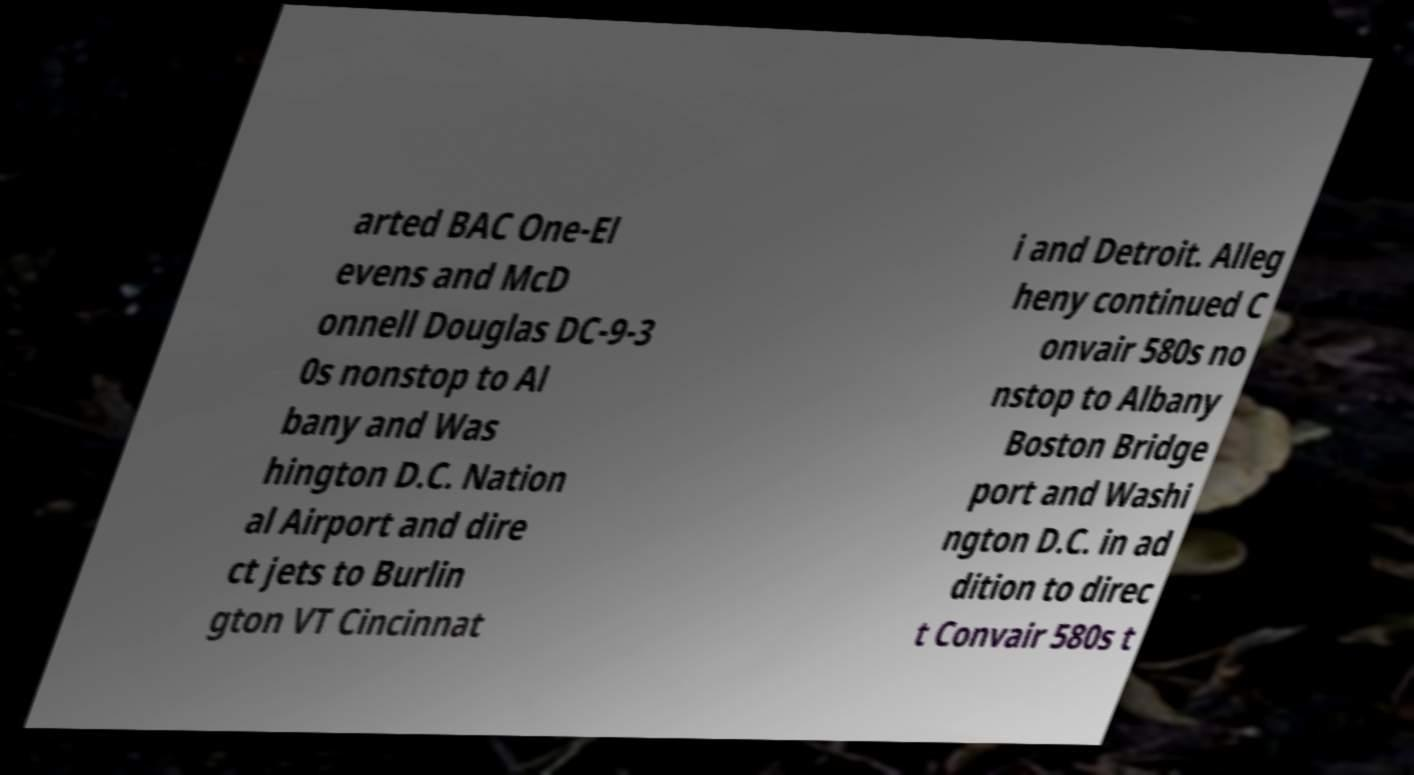Can you read and provide the text displayed in the image?This photo seems to have some interesting text. Can you extract and type it out for me? arted BAC One-El evens and McD onnell Douglas DC-9-3 0s nonstop to Al bany and Was hington D.C. Nation al Airport and dire ct jets to Burlin gton VT Cincinnat i and Detroit. Alleg heny continued C onvair 580s no nstop to Albany Boston Bridge port and Washi ngton D.C. in ad dition to direc t Convair 580s t 